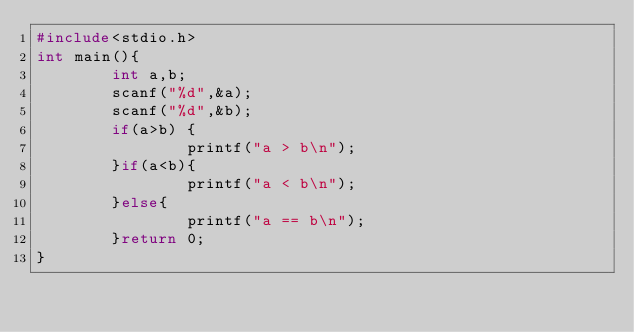Convert code to text. <code><loc_0><loc_0><loc_500><loc_500><_C_>#include<stdio.h>
int main(){
        int a,b;
        scanf("%d",&a);
        scanf("%d",&b);
        if(a>b) {
                printf("a > b\n");
        }if(a<b){
                printf("a < b\n");
        }else{
                printf("a == b\n");
        }return 0;
}</code> 